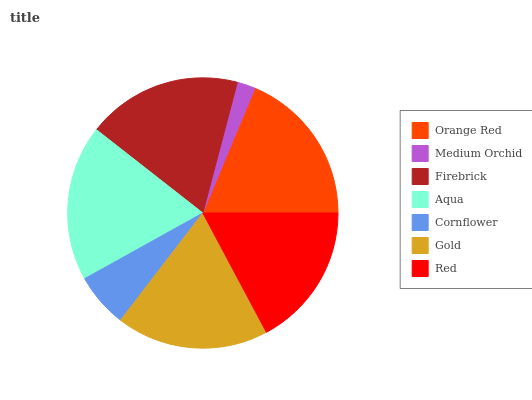Is Medium Orchid the minimum?
Answer yes or no. Yes. Is Orange Red the maximum?
Answer yes or no. Yes. Is Firebrick the minimum?
Answer yes or no. No. Is Firebrick the maximum?
Answer yes or no. No. Is Firebrick greater than Medium Orchid?
Answer yes or no. Yes. Is Medium Orchid less than Firebrick?
Answer yes or no. Yes. Is Medium Orchid greater than Firebrick?
Answer yes or no. No. Is Firebrick less than Medium Orchid?
Answer yes or no. No. Is Gold the high median?
Answer yes or no. Yes. Is Gold the low median?
Answer yes or no. Yes. Is Medium Orchid the high median?
Answer yes or no. No. Is Cornflower the low median?
Answer yes or no. No. 